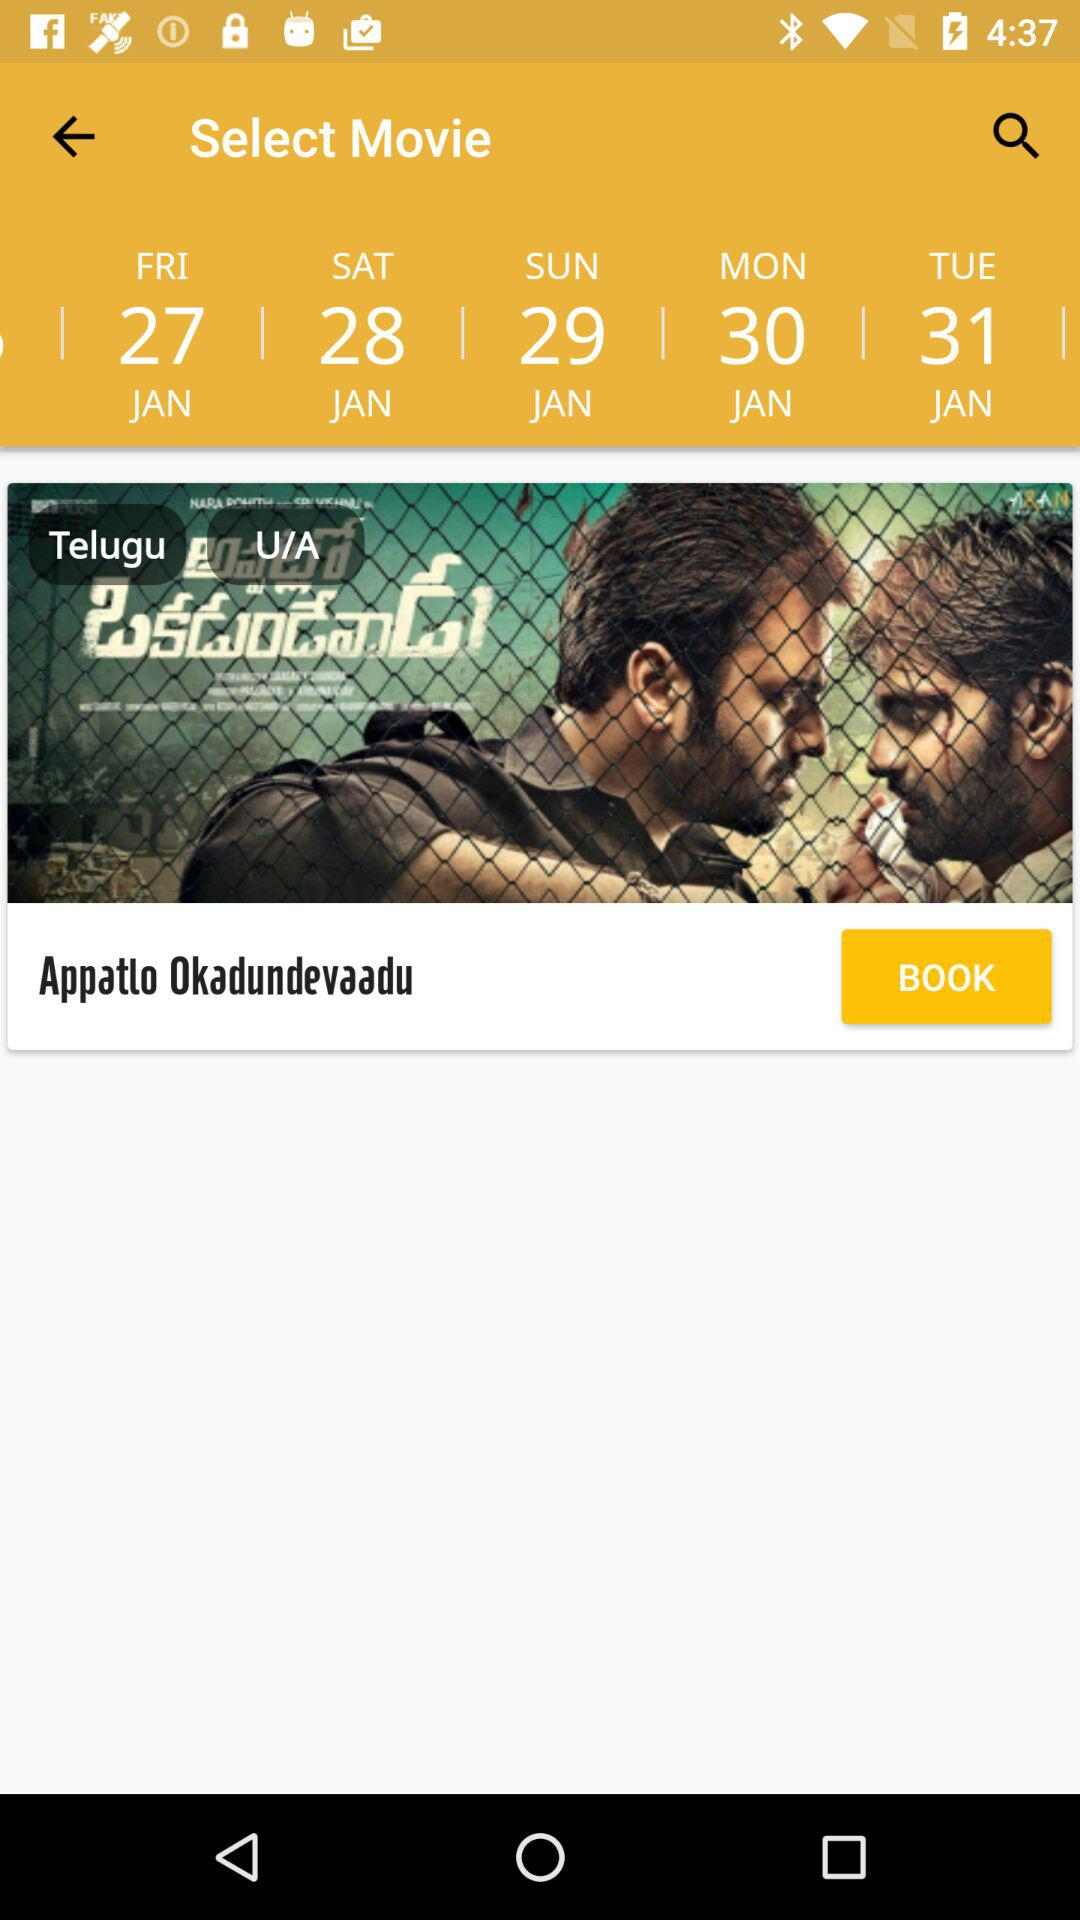What's the language of the movie? The language of the movie is Telugu. 